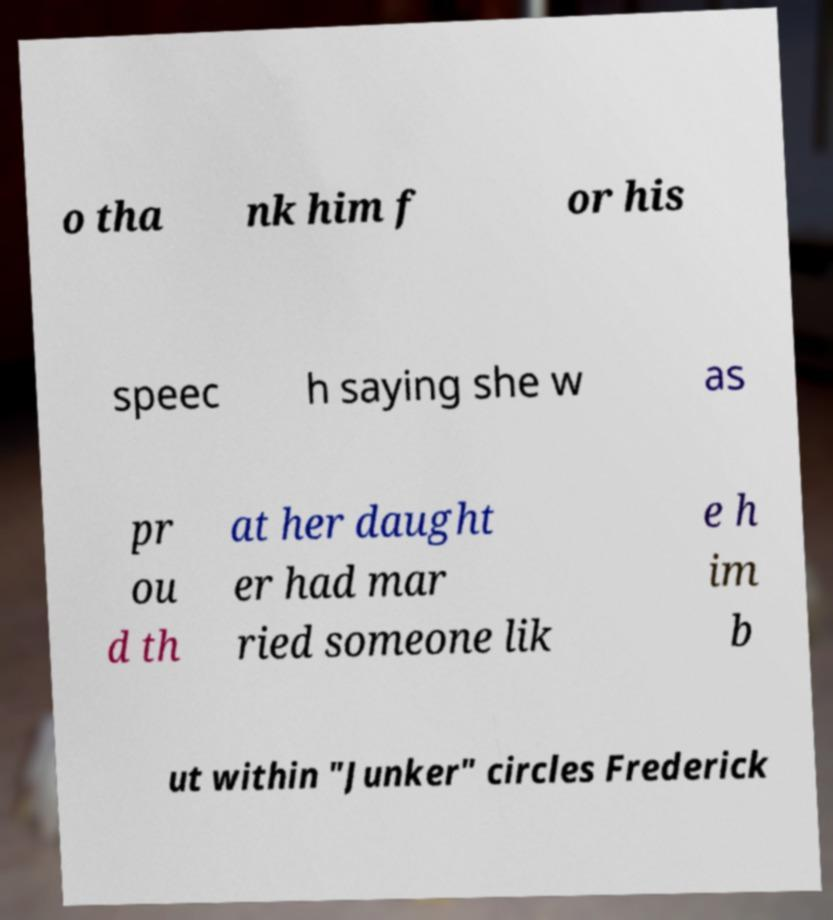What messages or text are displayed in this image? I need them in a readable, typed format. o tha nk him f or his speec h saying she w as pr ou d th at her daught er had mar ried someone lik e h im b ut within "Junker" circles Frederick 